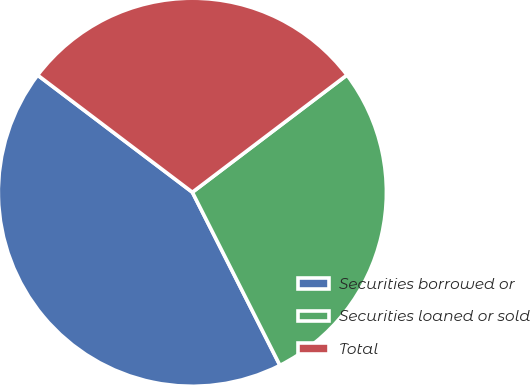Convert chart to OTSL. <chart><loc_0><loc_0><loc_500><loc_500><pie_chart><fcel>Securities borrowed or<fcel>Securities loaned or sold<fcel>Total<nl><fcel>42.76%<fcel>27.87%<fcel>29.36%<nl></chart> 